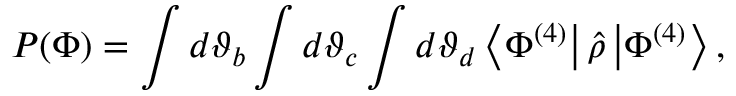<formula> <loc_0><loc_0><loc_500><loc_500>P ( \Phi ) = \int d \vartheta _ { b } \int d \vartheta _ { c } \int d \vartheta _ { d } \left \langle \Phi ^ { ( 4 ) } \right | \hat { \rho } \left | \Phi ^ { ( 4 ) } \right \rangle ,</formula> 